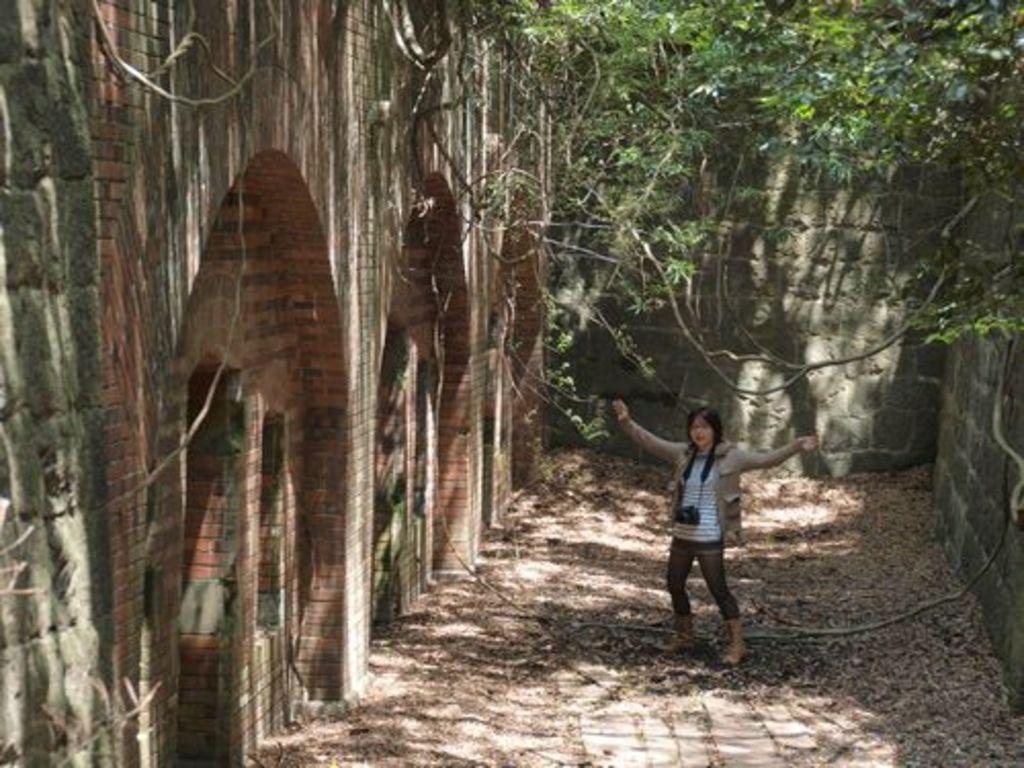Describe this image in one or two sentences. In this picture we can see a woman standing on the ground, she is wearing a camera and in the background we can see a wall, trees, dried leaves. 